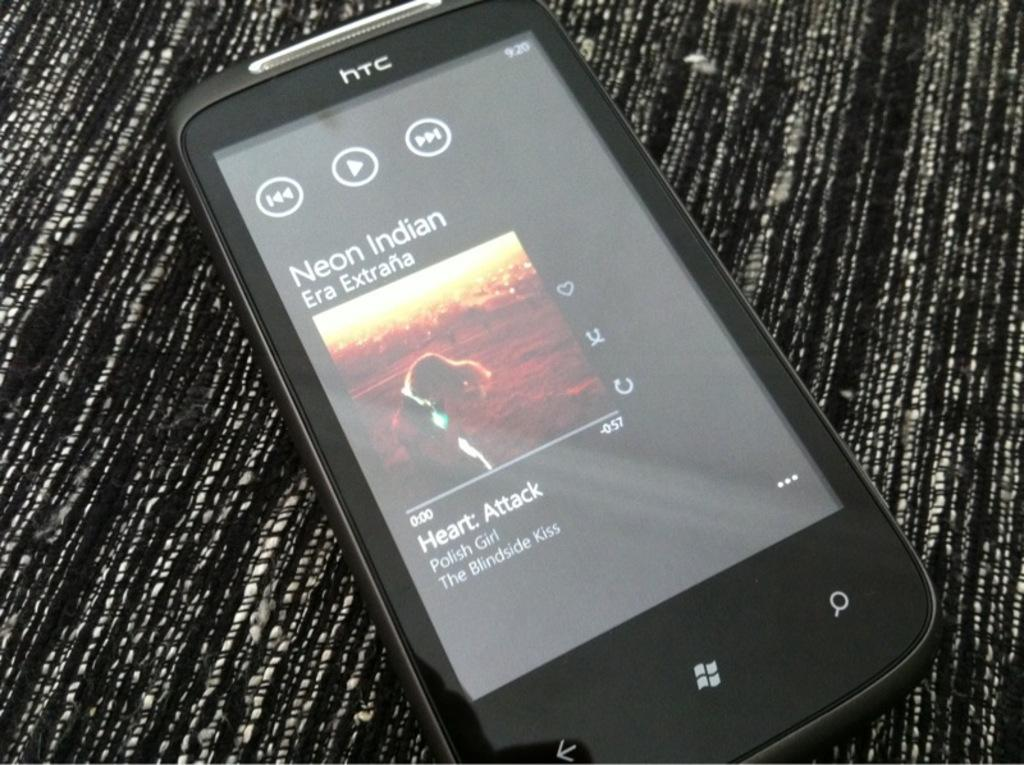Provide a one-sentence caption for the provided image. An HTC phone is playing a Neon Indian track. 